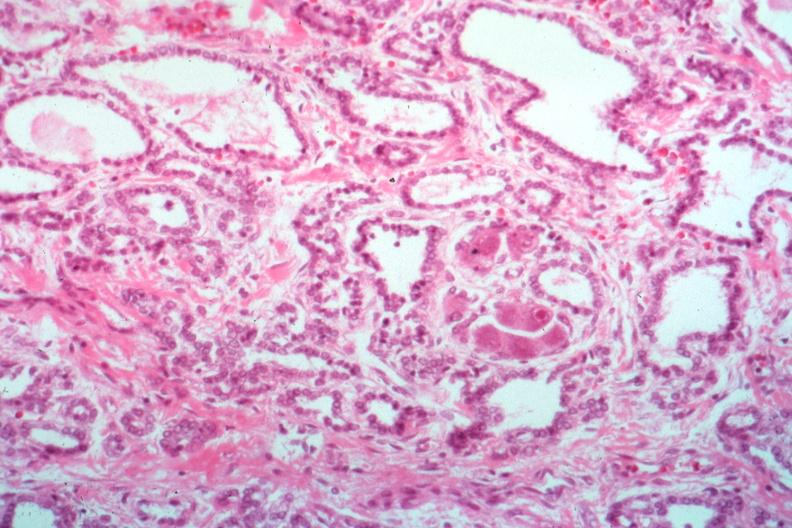s endocrine present?
Answer the question using a single word or phrase. Yes 